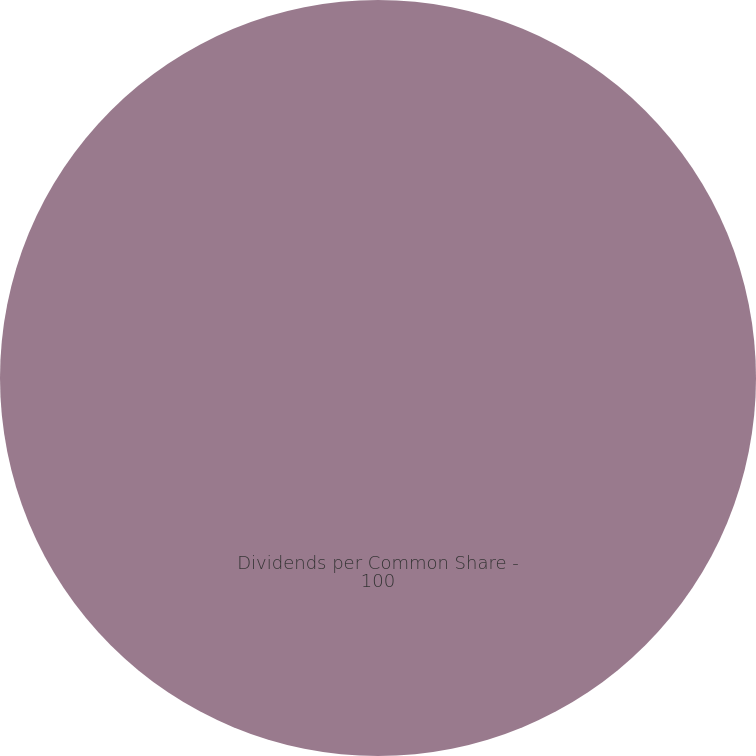Convert chart to OTSL. <chart><loc_0><loc_0><loc_500><loc_500><pie_chart><fcel>Dividends per Common Share -<nl><fcel>100.0%<nl></chart> 